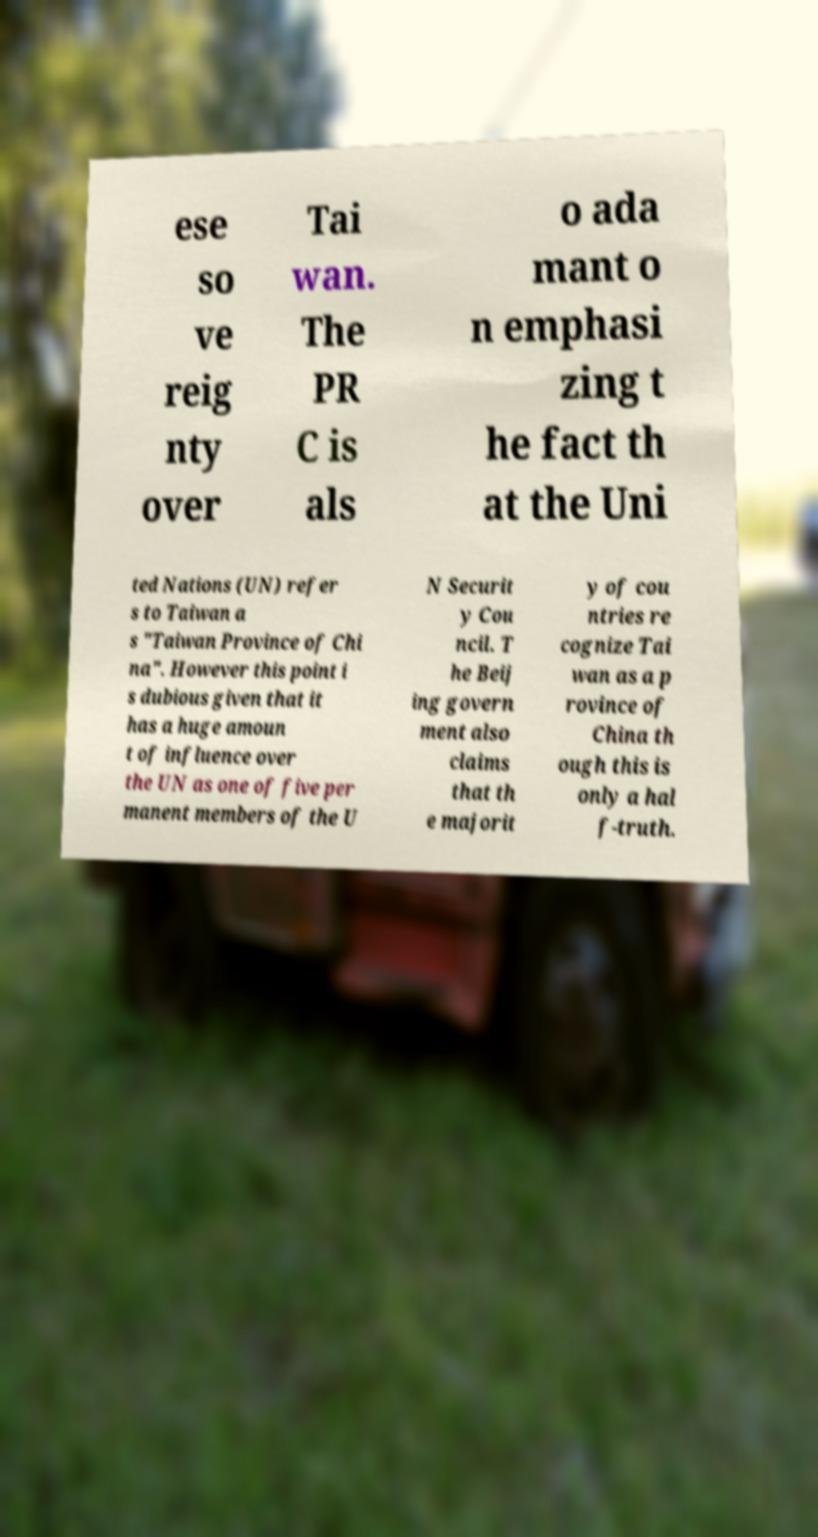Please identify and transcribe the text found in this image. ese so ve reig nty over Tai wan. The PR C is als o ada mant o n emphasi zing t he fact th at the Uni ted Nations (UN) refer s to Taiwan a s "Taiwan Province of Chi na". However this point i s dubious given that it has a huge amoun t of influence over the UN as one of five per manent members of the U N Securit y Cou ncil. T he Beij ing govern ment also claims that th e majorit y of cou ntries re cognize Tai wan as a p rovince of China th ough this is only a hal f-truth. 